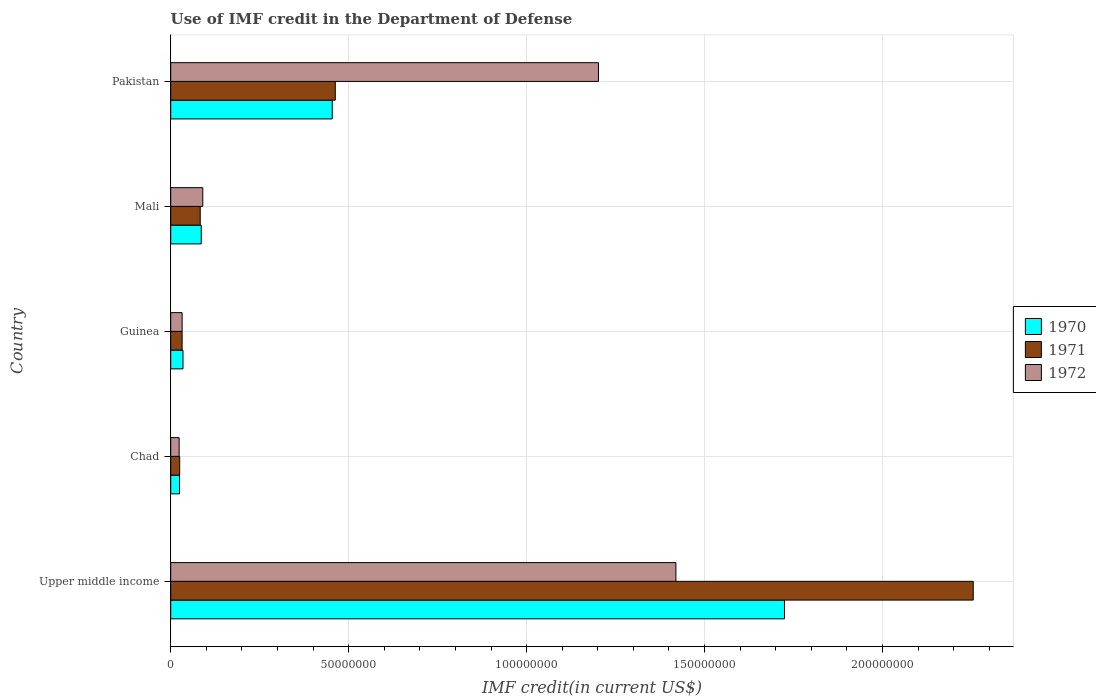How many groups of bars are there?
Keep it short and to the point. 5. How many bars are there on the 5th tick from the top?
Ensure brevity in your answer.  3. What is the label of the 1st group of bars from the top?
Offer a very short reply. Pakistan. In how many cases, is the number of bars for a given country not equal to the number of legend labels?
Make the answer very short. 0. What is the IMF credit in the Department of Defense in 1971 in Guinea?
Make the answer very short. 3.20e+06. Across all countries, what is the maximum IMF credit in the Department of Defense in 1970?
Make the answer very short. 1.72e+08. Across all countries, what is the minimum IMF credit in the Department of Defense in 1970?
Give a very brief answer. 2.47e+06. In which country was the IMF credit in the Department of Defense in 1972 maximum?
Offer a terse response. Upper middle income. In which country was the IMF credit in the Department of Defense in 1971 minimum?
Offer a very short reply. Chad. What is the total IMF credit in the Department of Defense in 1970 in the graph?
Your answer should be very brief. 2.32e+08. What is the difference between the IMF credit in the Department of Defense in 1970 in Chad and that in Mali?
Offer a very short reply. -6.11e+06. What is the difference between the IMF credit in the Department of Defense in 1971 in Chad and the IMF credit in the Department of Defense in 1970 in Guinea?
Keep it short and to the point. -9.31e+05. What is the average IMF credit in the Department of Defense in 1970 per country?
Provide a succinct answer. 4.65e+07. What is the difference between the IMF credit in the Department of Defense in 1970 and IMF credit in the Department of Defense in 1971 in Upper middle income?
Your answer should be compact. -5.30e+07. What is the ratio of the IMF credit in the Department of Defense in 1972 in Chad to that in Pakistan?
Give a very brief answer. 0.02. What is the difference between the highest and the second highest IMF credit in the Department of Defense in 1971?
Offer a very short reply. 1.79e+08. What is the difference between the highest and the lowest IMF credit in the Department of Defense in 1970?
Your answer should be compact. 1.70e+08. In how many countries, is the IMF credit in the Department of Defense in 1971 greater than the average IMF credit in the Department of Defense in 1971 taken over all countries?
Your answer should be very brief. 1. What does the 2nd bar from the top in Upper middle income represents?
Your answer should be very brief. 1971. How many bars are there?
Offer a terse response. 15. Does the graph contain any zero values?
Provide a succinct answer. No. Does the graph contain grids?
Your answer should be very brief. Yes. How are the legend labels stacked?
Ensure brevity in your answer.  Vertical. What is the title of the graph?
Provide a short and direct response. Use of IMF credit in the Department of Defense. What is the label or title of the X-axis?
Make the answer very short. IMF credit(in current US$). What is the IMF credit(in current US$) in 1970 in Upper middle income?
Keep it short and to the point. 1.72e+08. What is the IMF credit(in current US$) of 1971 in Upper middle income?
Make the answer very short. 2.25e+08. What is the IMF credit(in current US$) of 1972 in Upper middle income?
Your answer should be compact. 1.42e+08. What is the IMF credit(in current US$) of 1970 in Chad?
Your answer should be compact. 2.47e+06. What is the IMF credit(in current US$) of 1971 in Chad?
Your answer should be very brief. 2.52e+06. What is the IMF credit(in current US$) in 1972 in Chad?
Provide a succinct answer. 2.37e+06. What is the IMF credit(in current US$) of 1970 in Guinea?
Make the answer very short. 3.45e+06. What is the IMF credit(in current US$) of 1971 in Guinea?
Make the answer very short. 3.20e+06. What is the IMF credit(in current US$) of 1972 in Guinea?
Your answer should be very brief. 3.20e+06. What is the IMF credit(in current US$) of 1970 in Mali?
Make the answer very short. 8.58e+06. What is the IMF credit(in current US$) of 1971 in Mali?
Give a very brief answer. 8.30e+06. What is the IMF credit(in current US$) of 1972 in Mali?
Ensure brevity in your answer.  9.01e+06. What is the IMF credit(in current US$) of 1970 in Pakistan?
Offer a terse response. 4.54e+07. What is the IMF credit(in current US$) in 1971 in Pakistan?
Provide a short and direct response. 4.62e+07. What is the IMF credit(in current US$) of 1972 in Pakistan?
Give a very brief answer. 1.20e+08. Across all countries, what is the maximum IMF credit(in current US$) of 1970?
Offer a very short reply. 1.72e+08. Across all countries, what is the maximum IMF credit(in current US$) in 1971?
Give a very brief answer. 2.25e+08. Across all countries, what is the maximum IMF credit(in current US$) of 1972?
Provide a succinct answer. 1.42e+08. Across all countries, what is the minimum IMF credit(in current US$) of 1970?
Offer a very short reply. 2.47e+06. Across all countries, what is the minimum IMF credit(in current US$) of 1971?
Offer a terse response. 2.52e+06. Across all countries, what is the minimum IMF credit(in current US$) of 1972?
Your answer should be compact. 2.37e+06. What is the total IMF credit(in current US$) in 1970 in the graph?
Give a very brief answer. 2.32e+08. What is the total IMF credit(in current US$) of 1971 in the graph?
Provide a short and direct response. 2.86e+08. What is the total IMF credit(in current US$) of 1972 in the graph?
Ensure brevity in your answer.  2.77e+08. What is the difference between the IMF credit(in current US$) of 1970 in Upper middle income and that in Chad?
Make the answer very short. 1.70e+08. What is the difference between the IMF credit(in current US$) in 1971 in Upper middle income and that in Chad?
Your answer should be compact. 2.23e+08. What is the difference between the IMF credit(in current US$) in 1972 in Upper middle income and that in Chad?
Ensure brevity in your answer.  1.40e+08. What is the difference between the IMF credit(in current US$) in 1970 in Upper middle income and that in Guinea?
Keep it short and to the point. 1.69e+08. What is the difference between the IMF credit(in current US$) of 1971 in Upper middle income and that in Guinea?
Provide a short and direct response. 2.22e+08. What is the difference between the IMF credit(in current US$) in 1972 in Upper middle income and that in Guinea?
Ensure brevity in your answer.  1.39e+08. What is the difference between the IMF credit(in current US$) in 1970 in Upper middle income and that in Mali?
Provide a short and direct response. 1.64e+08. What is the difference between the IMF credit(in current US$) in 1971 in Upper middle income and that in Mali?
Your response must be concise. 2.17e+08. What is the difference between the IMF credit(in current US$) in 1972 in Upper middle income and that in Mali?
Your answer should be compact. 1.33e+08. What is the difference between the IMF credit(in current US$) of 1970 in Upper middle income and that in Pakistan?
Offer a terse response. 1.27e+08. What is the difference between the IMF credit(in current US$) of 1971 in Upper middle income and that in Pakistan?
Ensure brevity in your answer.  1.79e+08. What is the difference between the IMF credit(in current US$) of 1972 in Upper middle income and that in Pakistan?
Offer a very short reply. 2.18e+07. What is the difference between the IMF credit(in current US$) of 1970 in Chad and that in Guinea?
Offer a very short reply. -9.80e+05. What is the difference between the IMF credit(in current US$) of 1971 in Chad and that in Guinea?
Your response must be concise. -6.84e+05. What is the difference between the IMF credit(in current US$) of 1972 in Chad and that in Guinea?
Offer a terse response. -8.36e+05. What is the difference between the IMF credit(in current US$) of 1970 in Chad and that in Mali?
Offer a terse response. -6.11e+06. What is the difference between the IMF credit(in current US$) in 1971 in Chad and that in Mali?
Your answer should be compact. -5.78e+06. What is the difference between the IMF credit(in current US$) of 1972 in Chad and that in Mali?
Give a very brief answer. -6.64e+06. What is the difference between the IMF credit(in current US$) in 1970 in Chad and that in Pakistan?
Ensure brevity in your answer.  -4.29e+07. What is the difference between the IMF credit(in current US$) in 1971 in Chad and that in Pakistan?
Provide a short and direct response. -4.37e+07. What is the difference between the IMF credit(in current US$) of 1972 in Chad and that in Pakistan?
Make the answer very short. -1.18e+08. What is the difference between the IMF credit(in current US$) in 1970 in Guinea and that in Mali?
Your answer should be very brief. -5.13e+06. What is the difference between the IMF credit(in current US$) in 1971 in Guinea and that in Mali?
Offer a terse response. -5.09e+06. What is the difference between the IMF credit(in current US$) in 1972 in Guinea and that in Mali?
Provide a short and direct response. -5.81e+06. What is the difference between the IMF credit(in current US$) of 1970 in Guinea and that in Pakistan?
Provide a short and direct response. -4.19e+07. What is the difference between the IMF credit(in current US$) in 1971 in Guinea and that in Pakistan?
Your response must be concise. -4.30e+07. What is the difference between the IMF credit(in current US$) in 1972 in Guinea and that in Pakistan?
Offer a terse response. -1.17e+08. What is the difference between the IMF credit(in current US$) of 1970 in Mali and that in Pakistan?
Your response must be concise. -3.68e+07. What is the difference between the IMF credit(in current US$) of 1971 in Mali and that in Pakistan?
Your answer should be very brief. -3.79e+07. What is the difference between the IMF credit(in current US$) in 1972 in Mali and that in Pakistan?
Your answer should be very brief. -1.11e+08. What is the difference between the IMF credit(in current US$) in 1970 in Upper middle income and the IMF credit(in current US$) in 1971 in Chad?
Offer a terse response. 1.70e+08. What is the difference between the IMF credit(in current US$) in 1970 in Upper middle income and the IMF credit(in current US$) in 1972 in Chad?
Ensure brevity in your answer.  1.70e+08. What is the difference between the IMF credit(in current US$) in 1971 in Upper middle income and the IMF credit(in current US$) in 1972 in Chad?
Provide a succinct answer. 2.23e+08. What is the difference between the IMF credit(in current US$) of 1970 in Upper middle income and the IMF credit(in current US$) of 1971 in Guinea?
Keep it short and to the point. 1.69e+08. What is the difference between the IMF credit(in current US$) of 1970 in Upper middle income and the IMF credit(in current US$) of 1972 in Guinea?
Keep it short and to the point. 1.69e+08. What is the difference between the IMF credit(in current US$) in 1971 in Upper middle income and the IMF credit(in current US$) in 1972 in Guinea?
Keep it short and to the point. 2.22e+08. What is the difference between the IMF credit(in current US$) of 1970 in Upper middle income and the IMF credit(in current US$) of 1971 in Mali?
Give a very brief answer. 1.64e+08. What is the difference between the IMF credit(in current US$) in 1970 in Upper middle income and the IMF credit(in current US$) in 1972 in Mali?
Provide a succinct answer. 1.63e+08. What is the difference between the IMF credit(in current US$) of 1971 in Upper middle income and the IMF credit(in current US$) of 1972 in Mali?
Give a very brief answer. 2.16e+08. What is the difference between the IMF credit(in current US$) in 1970 in Upper middle income and the IMF credit(in current US$) in 1971 in Pakistan?
Offer a very short reply. 1.26e+08. What is the difference between the IMF credit(in current US$) in 1970 in Upper middle income and the IMF credit(in current US$) in 1972 in Pakistan?
Provide a succinct answer. 5.23e+07. What is the difference between the IMF credit(in current US$) of 1971 in Upper middle income and the IMF credit(in current US$) of 1972 in Pakistan?
Make the answer very short. 1.05e+08. What is the difference between the IMF credit(in current US$) of 1970 in Chad and the IMF credit(in current US$) of 1971 in Guinea?
Offer a terse response. -7.33e+05. What is the difference between the IMF credit(in current US$) in 1970 in Chad and the IMF credit(in current US$) in 1972 in Guinea?
Offer a terse response. -7.33e+05. What is the difference between the IMF credit(in current US$) of 1971 in Chad and the IMF credit(in current US$) of 1972 in Guinea?
Your answer should be very brief. -6.84e+05. What is the difference between the IMF credit(in current US$) in 1970 in Chad and the IMF credit(in current US$) in 1971 in Mali?
Your answer should be compact. -5.82e+06. What is the difference between the IMF credit(in current US$) of 1970 in Chad and the IMF credit(in current US$) of 1972 in Mali?
Your response must be concise. -6.54e+06. What is the difference between the IMF credit(in current US$) in 1971 in Chad and the IMF credit(in current US$) in 1972 in Mali?
Give a very brief answer. -6.49e+06. What is the difference between the IMF credit(in current US$) of 1970 in Chad and the IMF credit(in current US$) of 1971 in Pakistan?
Your response must be concise. -4.38e+07. What is the difference between the IMF credit(in current US$) of 1970 in Chad and the IMF credit(in current US$) of 1972 in Pakistan?
Offer a terse response. -1.18e+08. What is the difference between the IMF credit(in current US$) in 1971 in Chad and the IMF credit(in current US$) in 1972 in Pakistan?
Provide a succinct answer. -1.18e+08. What is the difference between the IMF credit(in current US$) of 1970 in Guinea and the IMF credit(in current US$) of 1971 in Mali?
Offer a terse response. -4.84e+06. What is the difference between the IMF credit(in current US$) of 1970 in Guinea and the IMF credit(in current US$) of 1972 in Mali?
Your answer should be compact. -5.56e+06. What is the difference between the IMF credit(in current US$) of 1971 in Guinea and the IMF credit(in current US$) of 1972 in Mali?
Your answer should be very brief. -5.81e+06. What is the difference between the IMF credit(in current US$) of 1970 in Guinea and the IMF credit(in current US$) of 1971 in Pakistan?
Provide a short and direct response. -4.28e+07. What is the difference between the IMF credit(in current US$) of 1970 in Guinea and the IMF credit(in current US$) of 1972 in Pakistan?
Make the answer very short. -1.17e+08. What is the difference between the IMF credit(in current US$) of 1971 in Guinea and the IMF credit(in current US$) of 1972 in Pakistan?
Provide a short and direct response. -1.17e+08. What is the difference between the IMF credit(in current US$) in 1970 in Mali and the IMF credit(in current US$) in 1971 in Pakistan?
Your response must be concise. -3.77e+07. What is the difference between the IMF credit(in current US$) of 1970 in Mali and the IMF credit(in current US$) of 1972 in Pakistan?
Ensure brevity in your answer.  -1.12e+08. What is the difference between the IMF credit(in current US$) of 1971 in Mali and the IMF credit(in current US$) of 1972 in Pakistan?
Offer a terse response. -1.12e+08. What is the average IMF credit(in current US$) in 1970 per country?
Offer a very short reply. 4.65e+07. What is the average IMF credit(in current US$) of 1971 per country?
Your response must be concise. 5.71e+07. What is the average IMF credit(in current US$) in 1972 per country?
Provide a succinct answer. 5.53e+07. What is the difference between the IMF credit(in current US$) of 1970 and IMF credit(in current US$) of 1971 in Upper middle income?
Ensure brevity in your answer.  -5.30e+07. What is the difference between the IMF credit(in current US$) of 1970 and IMF credit(in current US$) of 1972 in Upper middle income?
Ensure brevity in your answer.  3.05e+07. What is the difference between the IMF credit(in current US$) in 1971 and IMF credit(in current US$) in 1972 in Upper middle income?
Provide a short and direct response. 8.35e+07. What is the difference between the IMF credit(in current US$) of 1970 and IMF credit(in current US$) of 1971 in Chad?
Make the answer very short. -4.90e+04. What is the difference between the IMF credit(in current US$) in 1970 and IMF credit(in current US$) in 1972 in Chad?
Offer a very short reply. 1.03e+05. What is the difference between the IMF credit(in current US$) in 1971 and IMF credit(in current US$) in 1972 in Chad?
Make the answer very short. 1.52e+05. What is the difference between the IMF credit(in current US$) in 1970 and IMF credit(in current US$) in 1971 in Guinea?
Offer a very short reply. 2.47e+05. What is the difference between the IMF credit(in current US$) in 1970 and IMF credit(in current US$) in 1972 in Guinea?
Your response must be concise. 2.47e+05. What is the difference between the IMF credit(in current US$) of 1970 and IMF credit(in current US$) of 1971 in Mali?
Offer a very short reply. 2.85e+05. What is the difference between the IMF credit(in current US$) of 1970 and IMF credit(in current US$) of 1972 in Mali?
Make the answer very short. -4.31e+05. What is the difference between the IMF credit(in current US$) in 1971 and IMF credit(in current US$) in 1972 in Mali?
Make the answer very short. -7.16e+05. What is the difference between the IMF credit(in current US$) in 1970 and IMF credit(in current US$) in 1971 in Pakistan?
Give a very brief answer. -8.56e+05. What is the difference between the IMF credit(in current US$) in 1970 and IMF credit(in current US$) in 1972 in Pakistan?
Make the answer very short. -7.48e+07. What is the difference between the IMF credit(in current US$) in 1971 and IMF credit(in current US$) in 1972 in Pakistan?
Give a very brief answer. -7.40e+07. What is the ratio of the IMF credit(in current US$) in 1970 in Upper middle income to that in Chad?
Your answer should be very brief. 69.82. What is the ratio of the IMF credit(in current US$) of 1971 in Upper middle income to that in Chad?
Keep it short and to the point. 89.51. What is the ratio of the IMF credit(in current US$) of 1972 in Upper middle income to that in Chad?
Provide a short and direct response. 59.97. What is the ratio of the IMF credit(in current US$) in 1970 in Upper middle income to that in Guinea?
Keep it short and to the point. 49.99. What is the ratio of the IMF credit(in current US$) in 1971 in Upper middle income to that in Guinea?
Your answer should be very brief. 70.4. What is the ratio of the IMF credit(in current US$) of 1972 in Upper middle income to that in Guinea?
Keep it short and to the point. 44.32. What is the ratio of the IMF credit(in current US$) of 1970 in Upper middle income to that in Mali?
Your answer should be compact. 20.1. What is the ratio of the IMF credit(in current US$) of 1971 in Upper middle income to that in Mali?
Keep it short and to the point. 27.18. What is the ratio of the IMF credit(in current US$) in 1972 in Upper middle income to that in Mali?
Keep it short and to the point. 15.75. What is the ratio of the IMF credit(in current US$) of 1970 in Upper middle income to that in Pakistan?
Offer a terse response. 3.8. What is the ratio of the IMF credit(in current US$) of 1971 in Upper middle income to that in Pakistan?
Provide a succinct answer. 4.88. What is the ratio of the IMF credit(in current US$) of 1972 in Upper middle income to that in Pakistan?
Make the answer very short. 1.18. What is the ratio of the IMF credit(in current US$) in 1970 in Chad to that in Guinea?
Provide a succinct answer. 0.72. What is the ratio of the IMF credit(in current US$) in 1971 in Chad to that in Guinea?
Give a very brief answer. 0.79. What is the ratio of the IMF credit(in current US$) in 1972 in Chad to that in Guinea?
Give a very brief answer. 0.74. What is the ratio of the IMF credit(in current US$) of 1970 in Chad to that in Mali?
Your answer should be very brief. 0.29. What is the ratio of the IMF credit(in current US$) of 1971 in Chad to that in Mali?
Your answer should be compact. 0.3. What is the ratio of the IMF credit(in current US$) of 1972 in Chad to that in Mali?
Your answer should be compact. 0.26. What is the ratio of the IMF credit(in current US$) in 1970 in Chad to that in Pakistan?
Your response must be concise. 0.05. What is the ratio of the IMF credit(in current US$) in 1971 in Chad to that in Pakistan?
Provide a succinct answer. 0.05. What is the ratio of the IMF credit(in current US$) in 1972 in Chad to that in Pakistan?
Your response must be concise. 0.02. What is the ratio of the IMF credit(in current US$) in 1970 in Guinea to that in Mali?
Your answer should be compact. 0.4. What is the ratio of the IMF credit(in current US$) in 1971 in Guinea to that in Mali?
Ensure brevity in your answer.  0.39. What is the ratio of the IMF credit(in current US$) in 1972 in Guinea to that in Mali?
Your answer should be very brief. 0.36. What is the ratio of the IMF credit(in current US$) of 1970 in Guinea to that in Pakistan?
Make the answer very short. 0.08. What is the ratio of the IMF credit(in current US$) in 1971 in Guinea to that in Pakistan?
Offer a terse response. 0.07. What is the ratio of the IMF credit(in current US$) of 1972 in Guinea to that in Pakistan?
Your response must be concise. 0.03. What is the ratio of the IMF credit(in current US$) in 1970 in Mali to that in Pakistan?
Give a very brief answer. 0.19. What is the ratio of the IMF credit(in current US$) of 1971 in Mali to that in Pakistan?
Your response must be concise. 0.18. What is the ratio of the IMF credit(in current US$) in 1972 in Mali to that in Pakistan?
Give a very brief answer. 0.07. What is the difference between the highest and the second highest IMF credit(in current US$) of 1970?
Provide a short and direct response. 1.27e+08. What is the difference between the highest and the second highest IMF credit(in current US$) in 1971?
Offer a very short reply. 1.79e+08. What is the difference between the highest and the second highest IMF credit(in current US$) in 1972?
Give a very brief answer. 2.18e+07. What is the difference between the highest and the lowest IMF credit(in current US$) of 1970?
Keep it short and to the point. 1.70e+08. What is the difference between the highest and the lowest IMF credit(in current US$) of 1971?
Give a very brief answer. 2.23e+08. What is the difference between the highest and the lowest IMF credit(in current US$) of 1972?
Your response must be concise. 1.40e+08. 